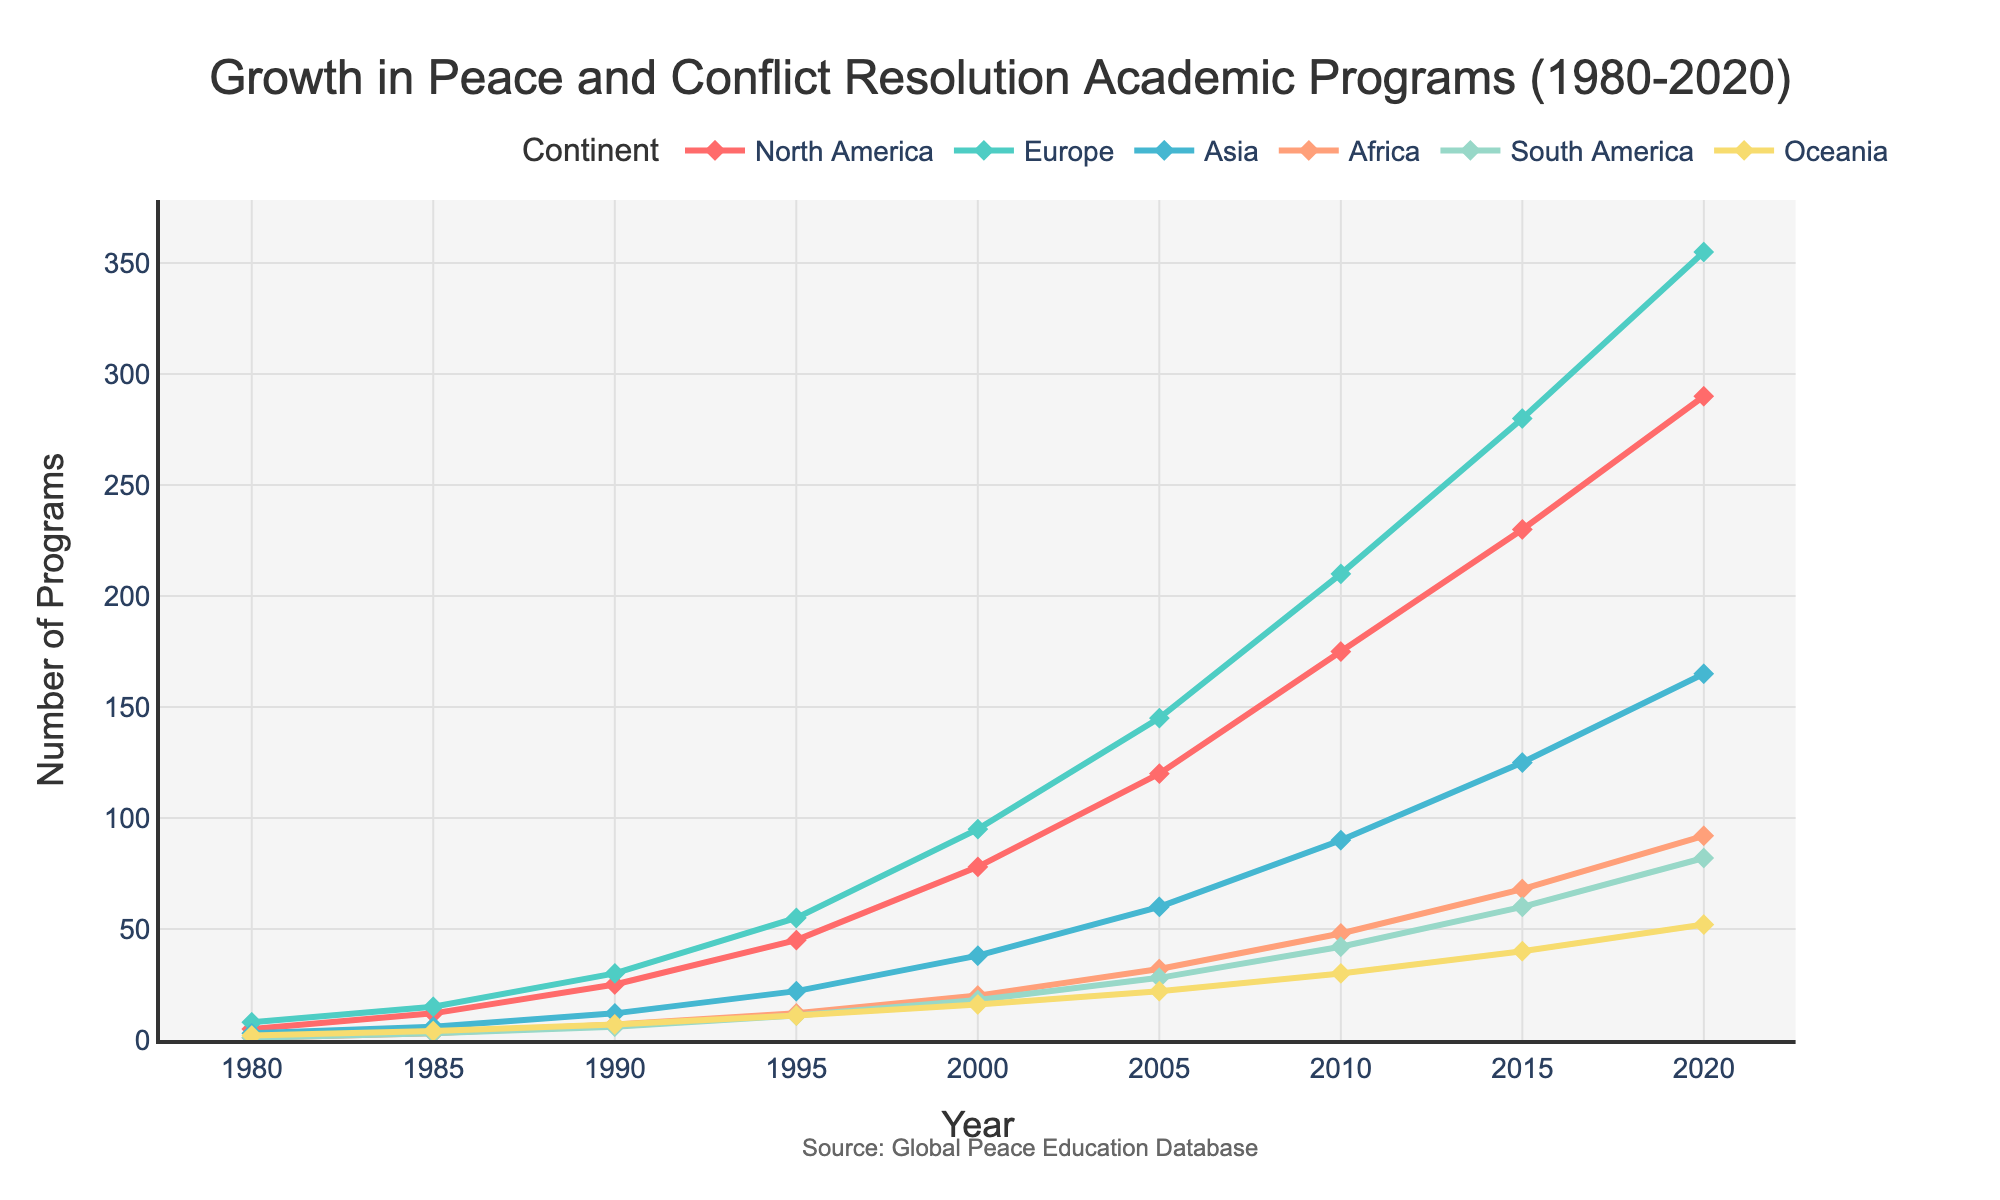What is the overall trend in the number of peace and conflict resolution academic programs globally from 1980 to 2020 across all continents? The overall trend shows a steady and significant increase in the number of programs globally across all continents from 1980 to 2020. Each continent's line rises, indicating growth in these academic programs over the 40-year period.
Answer: Steady increase Which continent had the highest number of peace and conflict resolution academic programs in 2020? By looking at the heights of the lines in 2020, Europe has the highest value among the continents.
Answer: Europe How does the number of programs in North America in 2000 compare to that in Asia in 2005? In 2000, North America has 78 programs. In 2005, Asia has 60 programs. Thus, North America had more programs in 2000 compared to Asia in 2005.
Answer: North America had more Which continent showed the fastest growth rate in the number of academic programs between 2010 and 2020? To find the fastest growth rate, calculate the difference in the number of programs for each continent between 2010 and 2020. North America grew from 175 to 290, a difference of 115. Europe grew from 210 to 355, a difference of 145. Asia grew from 90 to 165, a difference of 75. Africa grew from 48 to 92, a difference of 44. South America grew from 42 to 82, a difference of 40. Oceania grew from 30 to 52, a difference of 22. Europe has the highest growth.
Answer: Europe Compare the growth of peace and conflict resolution academic programs in South America and Africa from 1985 to 2000. Which continent had a greater increase? In 1985, South America had 3 programs, and in 2000, it had 18, an increase of 15. Africa had 3 programs in 1985 and 20 programs in 2000, an increase of 17. Africa had a greater increase.
Answer: Africa What was the average number of programs across all the continents in 1995? Sum the number of programs for all continents in 1995 and divide by the number of continents. (45+55+22+12+11+11)/6 = 156/6 = 26
Answer: 26 Which continent had the least number of programs in 1990, and how many programs were there? By comparing the values in 1990, Africa had the least with 7 programs.
Answer: Africa, 7 programs Estimate the total number of peace and conflict resolution academic programs globally in 1985 by summing up the values for all continents. Sum the numbers for each continent in 1985: 12 (North America) + 15 (Europe) + 6 (Asia) + 3 (Africa) + 3 (South America) + 4 (Oceania) = 43
Answer: 43 Identify the years when Oceania had exactly double the number of programs as Africa. In 1995: Oceania had 11 and Africa had 12 (not double). In 2000: Oceania had 16 and Africa had 20 (not double). In 2005: Oceania had 22 and Africa had 32 (not double). In 1985, Oceania had 4 and Africa had 3 (Not double).
Answer: No such years 